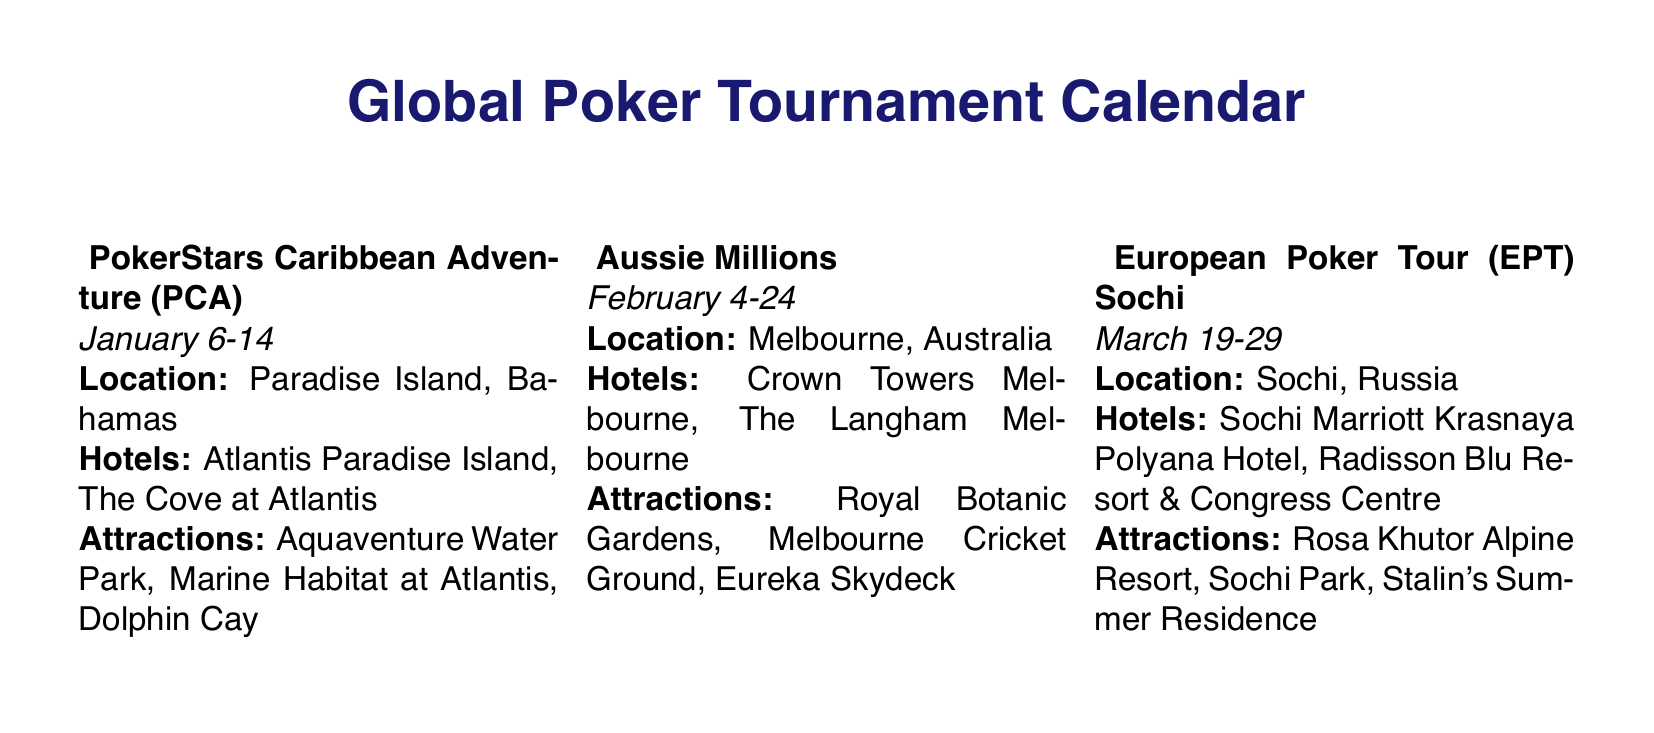what is the date for the PokerStars Caribbean Adventure? The document specifies that the tournament will take place from January 6 to January 14.
Answer: January 6-14 how many tournaments are scheduled in April? There are two tournaments listed in April: WPT Seminole Hard Rock Poker Showdown and Monte-Carlo EPT.
Answer: 2 what city hosts the EPT Barcelona? The document indicates that the EPT Barcelona is hosted in Barcelona, Spain.
Answer: Barcelona which hotel is recommended for the World Series of Poker? The recommended hotels for the WSOP include Bellagio Hotel & Casino and The Venetian Resort.
Answer: Bellagio Hotel & Casino, The Venetian Resort which local attraction is mentioned for the Monte-Carlo EPT? The local attractions for the Monte-Carlo EPT include Casino Square, Larvotto Beach, and Oceanographic Museum.
Answer: Casino Square what is the last tournament of the year? The last tournament listed in the calendar is the WSOP Circuit Aruba.
Answer: WSOP Circuit Aruba which country hosts the European Poker Tour (EPT) Sochi? The document states that Sochi, Russia, is the location for the EPT Sochi.
Answer: Russia what hotel is mentioned for the October tournament? The King's Casino Hotel is mentioned for the World Series of Poker Europe.
Answer: King's Casino Hotel 